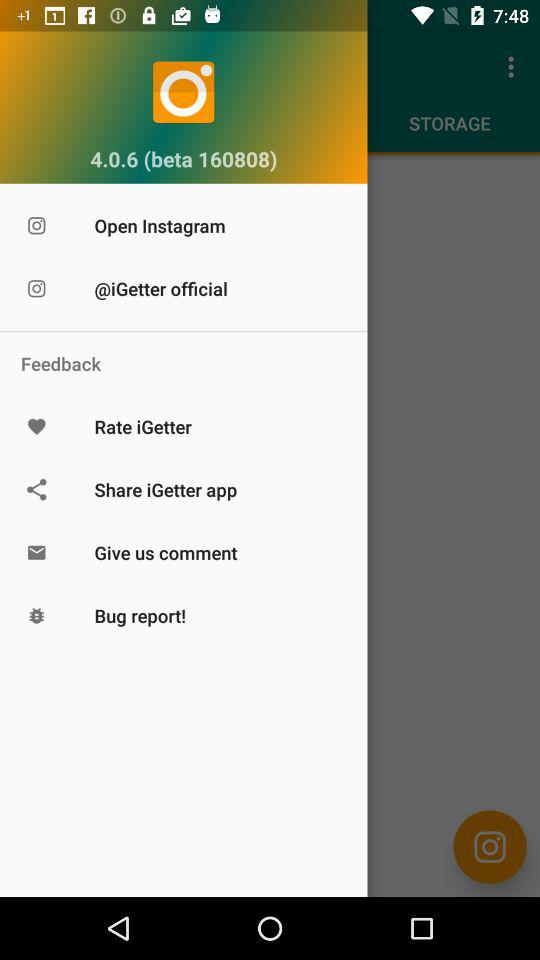How many more feedback items are there than sharing items?
Answer the question using a single word or phrase. 2 